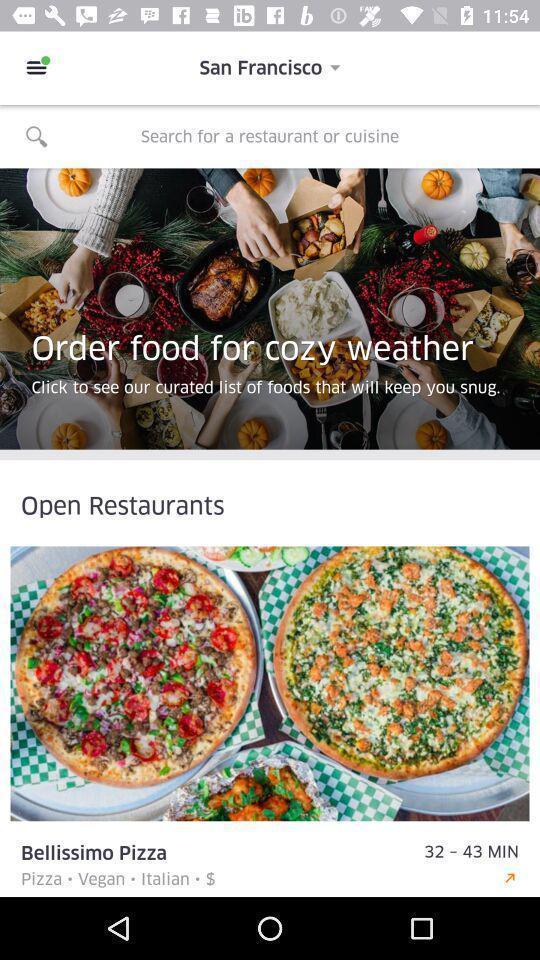Tell me about the visual elements in this screen capture. Screen shows display page of food delivery application. 